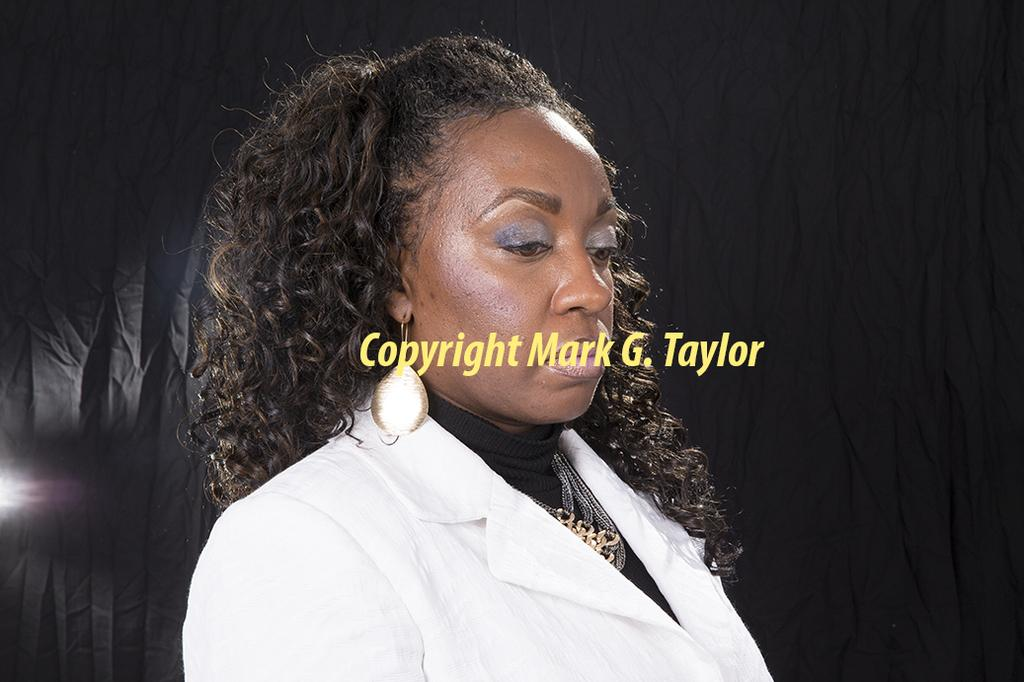Who is present in the image? There is a woman in the image. What is the woman wearing? The woman is wearing a white coat. Can you describe any text in the image? Yes, there is yellow text in the image. Is the woman holding a gun in the image? No, there is no gun present in the image. Can you tell me the price of the banana in the image? There is no banana present in the image, so it's not possible to determine its price. 